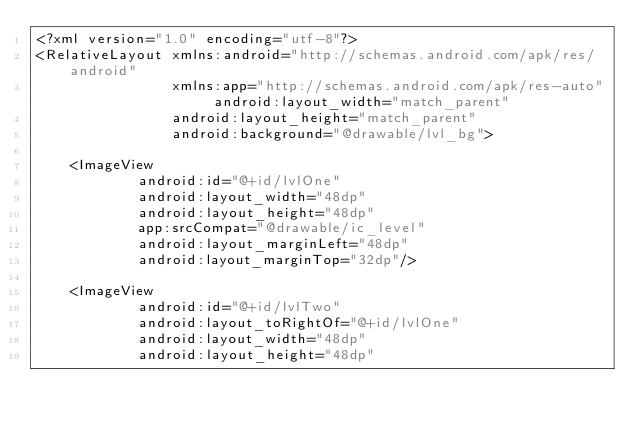Convert code to text. <code><loc_0><loc_0><loc_500><loc_500><_XML_><?xml version="1.0" encoding="utf-8"?>
<RelativeLayout xmlns:android="http://schemas.android.com/apk/res/android"
                xmlns:app="http://schemas.android.com/apk/res-auto" android:layout_width="match_parent"
                android:layout_height="match_parent"
                android:background="@drawable/lvl_bg">

    <ImageView
            android:id="@+id/lvlOne"
            android:layout_width="48dp"
            android:layout_height="48dp"
            app:srcCompat="@drawable/ic_level"
            android:layout_marginLeft="48dp"
            android:layout_marginTop="32dp"/>

    <ImageView
            android:id="@+id/lvlTwo"
            android:layout_toRightOf="@+id/lvlOne"
            android:layout_width="48dp"
            android:layout_height="48dp"</code> 